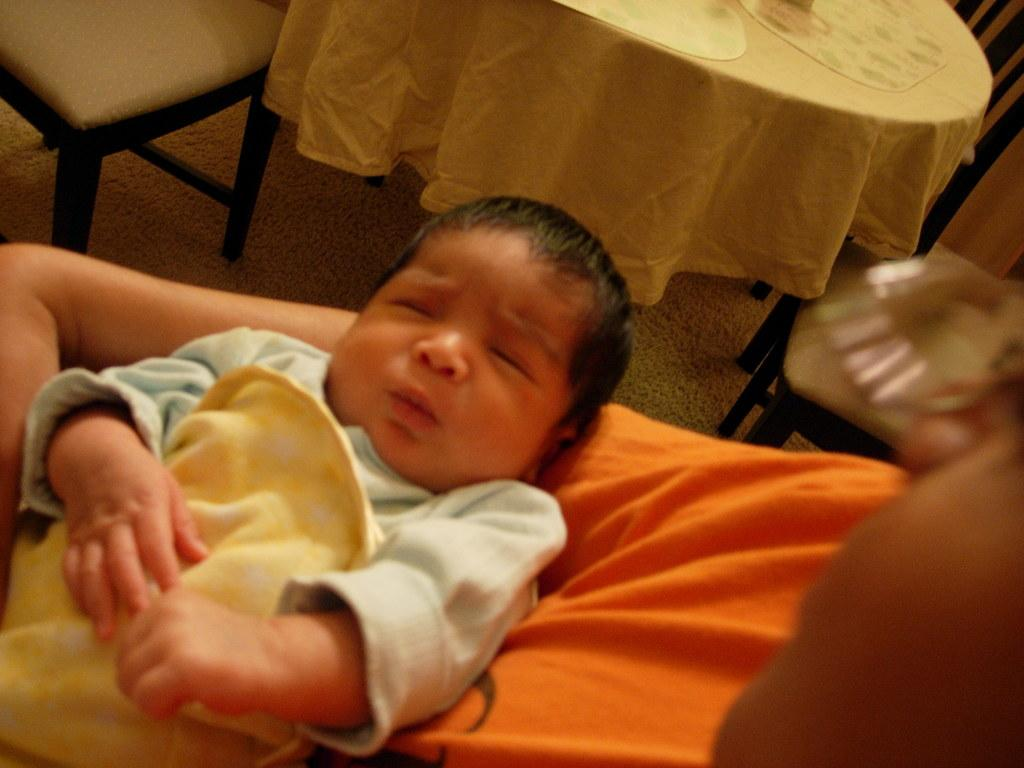What is the main subject of the image? There is a baby in the image. What can be seen in the background of the image? There is a floor, a table, a chair, a cloth, and some objects visible in the background of the image. Can you tell me how many planes are parked at the airport in the image? There is no airport or planes present in the image; it features a baby and various objects in the background. What type of help is being offered to the person experiencing death in the image? There is no person experiencing death or any type of help being offered in the image; it features a baby and various objects in the background. 